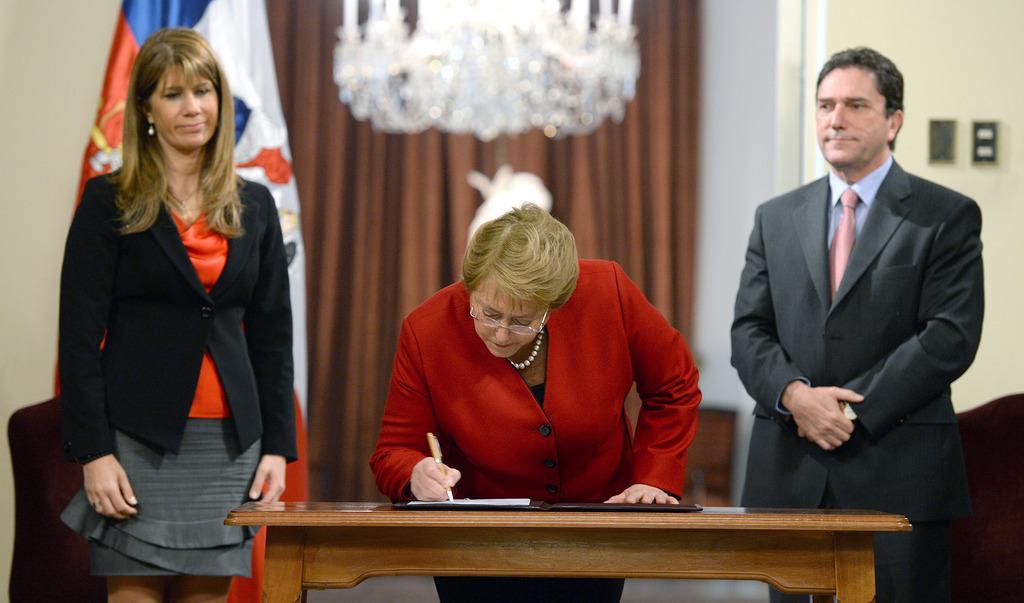Please provide a concise description of this image. In the picture there is a table and on the table there are some files,in front of that is a woman wearing red coat,she is signing on them,to the left side there is a woman standing,at the right side there is a man,behind them there is a flag,in the background there is a curtain and lights to the roof. 